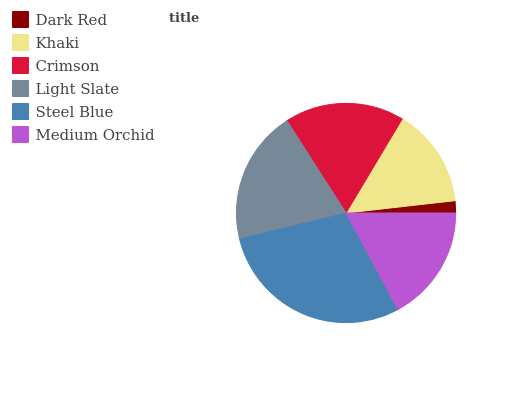Is Dark Red the minimum?
Answer yes or no. Yes. Is Steel Blue the maximum?
Answer yes or no. Yes. Is Khaki the minimum?
Answer yes or no. No. Is Khaki the maximum?
Answer yes or no. No. Is Khaki greater than Dark Red?
Answer yes or no. Yes. Is Dark Red less than Khaki?
Answer yes or no. Yes. Is Dark Red greater than Khaki?
Answer yes or no. No. Is Khaki less than Dark Red?
Answer yes or no. No. Is Crimson the high median?
Answer yes or no. Yes. Is Medium Orchid the low median?
Answer yes or no. Yes. Is Light Slate the high median?
Answer yes or no. No. Is Steel Blue the low median?
Answer yes or no. No. 